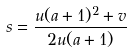Convert formula to latex. <formula><loc_0><loc_0><loc_500><loc_500>s = \frac { u ( a + 1 ) ^ { 2 } + v } { 2 u ( a + 1 ) }</formula> 